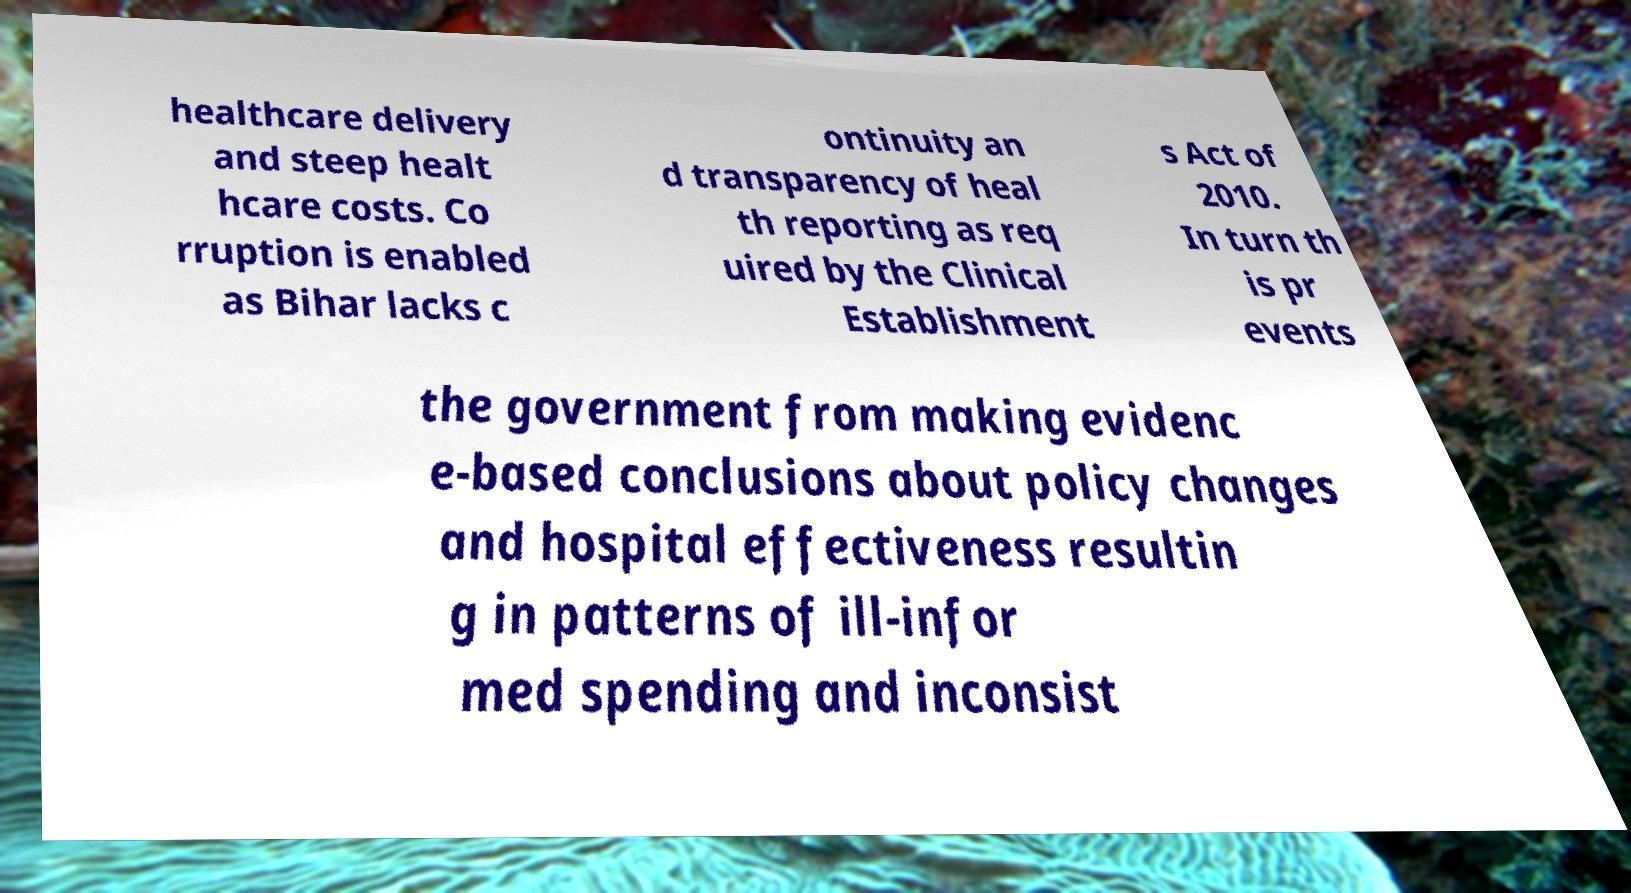Please identify and transcribe the text found in this image. healthcare delivery and steep healt hcare costs. Co rruption is enabled as Bihar lacks c ontinuity an d transparency of heal th reporting as req uired by the Clinical Establishment s Act of 2010. In turn th is pr events the government from making evidenc e-based conclusions about policy changes and hospital effectiveness resultin g in patterns of ill-infor med spending and inconsist 